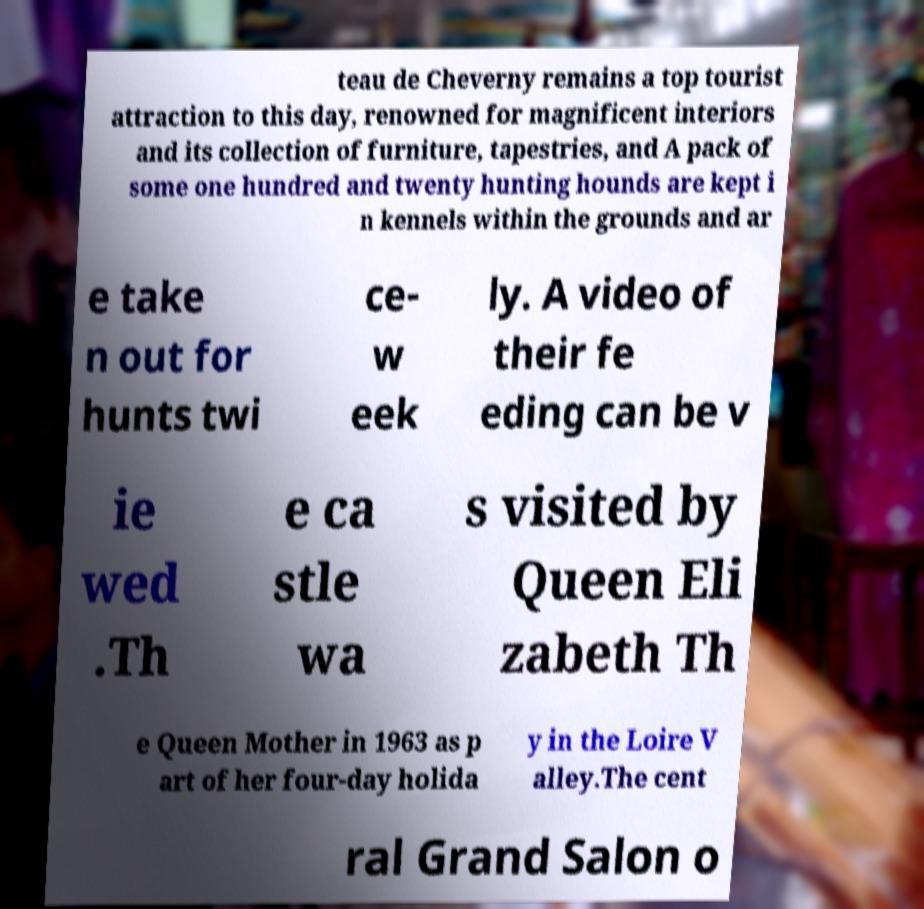Could you extract and type out the text from this image? teau de Cheverny remains a top tourist attraction to this day, renowned for magnificent interiors and its collection of furniture, tapestries, and A pack of some one hundred and twenty hunting hounds are kept i n kennels within the grounds and ar e take n out for hunts twi ce- w eek ly. A video of their fe eding can be v ie wed .Th e ca stle wa s visited by Queen Eli zabeth Th e Queen Mother in 1963 as p art of her four-day holida y in the Loire V alley.The cent ral Grand Salon o 